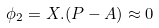<formula> <loc_0><loc_0><loc_500><loc_500>\phi _ { 2 } = X . ( P - A ) \approx 0</formula> 